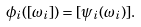Convert formula to latex. <formula><loc_0><loc_0><loc_500><loc_500>\phi _ { i } ( [ \omega _ { i } ] ) = [ \psi _ { i } ( \omega _ { i } ) ] .</formula> 